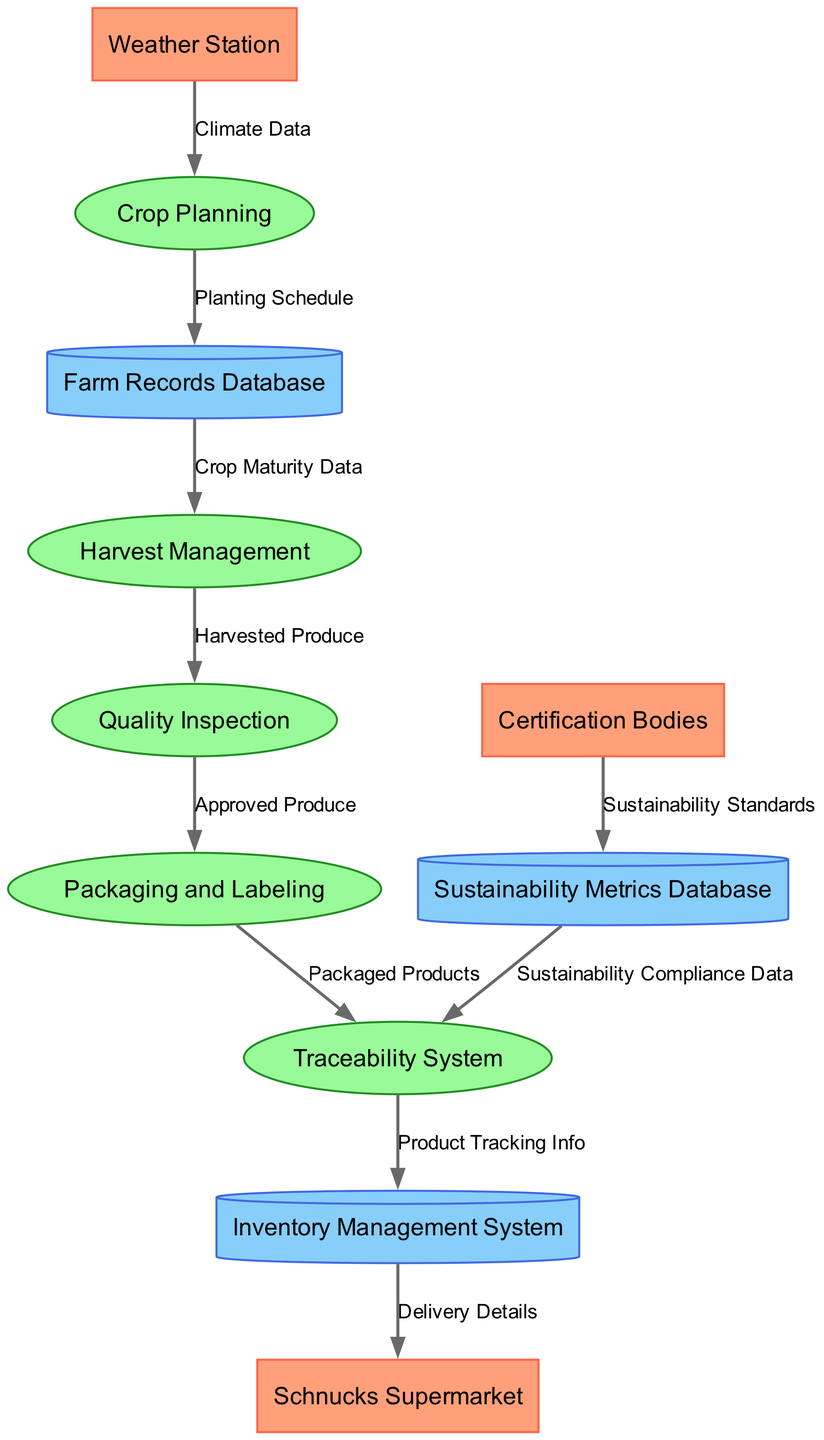What external entity is responsible for delivering produce to Schnucks? The diagram shows an arrow from the Inventory Management System to Schnucks Supermarket, indicating that this system manages the delivery details to Schnucks.
Answer: Inventory Management System How many processes are defined in this diagram? The diagram lists five processes, which are Crop Planning, Harvest Management, Quality Inspection, Packaging and Labeling, and Traceability System.
Answer: Five What data flow is from the Weather Station to Crop Planning? The label on the arrow from Weather Station to Crop Planning indicates that the data flow is labeled as Climate Data.
Answer: Climate Data Which data store is fed by the Certification Bodies? The arrow from Certification Bodies points to the Sustainability Metrics Database, indicating that this database receives the sustainability standards.
Answer: Sustainability Metrics Database What is tracked by the Traceability System? The diagram indicates that the Traceability System receives Packaged Products from Packaging and Labeling, and it also directs Sustainability Compliance Data from the Sustainability Metrics Database.
Answer: Packaged Products Which process directly follows Harvest Management? The flow of data from Harvest Management leads directly to Quality Inspection, indicating that Quality Inspection is the next process.
Answer: Quality Inspection What type of data does the Sustainability Metrics Database provide to the Traceability System? From the diagram, we see that the Sustainability Metrics Database sends Sustainability Compliance Data to the Traceability System, which means it ensures that sustainability metrics are considered in traceability.
Answer: Sustainability Compliance Data How many external entities are shown in the diagram? The diagram includes three external entities: Schnucks Supermarket, Certification Bodies, and Weather Station, which represents the stakeholders involved.
Answer: Three What process handles the approved produce? The Quality Inspection process is responsible for handling the Approved Produce before it moves to Packaging and Labeling.
Answer: Quality Inspection 